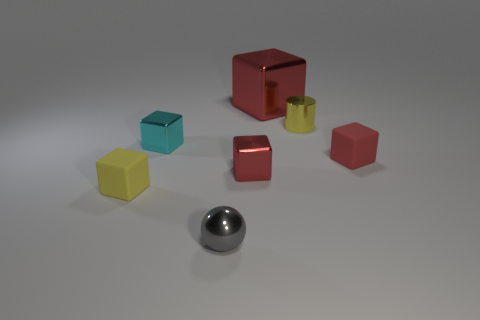There is a small metallic object in front of the yellow rubber object; what shape is it?
Offer a terse response. Sphere. Are there any small gray shiny spheres in front of the large red metallic object?
Your answer should be compact. Yes. There is a big object that is made of the same material as the tiny cylinder; what color is it?
Offer a very short reply. Red. Do the block that is right of the big red block and the matte object on the left side of the gray shiny object have the same color?
Keep it short and to the point. No. What number of balls are either red metal things or large shiny things?
Your response must be concise. 0. Are there the same number of yellow metal things that are in front of the tiny shiny sphere and red metal blocks?
Your answer should be compact. No. There is a tiny yellow object that is in front of the metal block in front of the rubber cube that is behind the tiny yellow cube; what is its material?
Ensure brevity in your answer.  Rubber. There is a cube that is the same color as the small shiny cylinder; what material is it?
Ensure brevity in your answer.  Rubber. How many objects are matte things that are in front of the red rubber cube or shiny spheres?
Make the answer very short. 2. How many things are either small blue rubber cylinders or yellow objects that are behind the small yellow cube?
Keep it short and to the point. 1. 